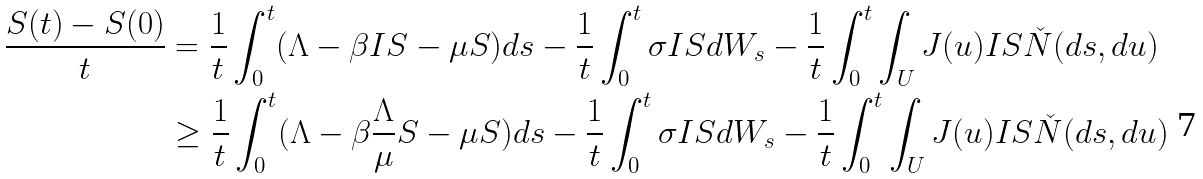Convert formula to latex. <formula><loc_0><loc_0><loc_500><loc_500>\frac { S ( t ) - S ( 0 ) } { t } & = \frac { 1 } { t } \int _ { 0 } ^ { t } ( \Lambda - \beta I S - \mu S ) d s - \frac { 1 } { t } \int _ { 0 } ^ { t } \sigma I S d W _ { s } - \frac { 1 } { t } \int _ { 0 } ^ { t } \int _ { U } J ( u ) I S \check { N } ( d s , d u ) \\ & \geq \frac { 1 } { t } \int _ { 0 } ^ { t } ( \Lambda - \beta \frac { \Lambda } { \mu } S - \mu S ) d s - \frac { 1 } { t } \int _ { 0 } ^ { t } \sigma I S d W _ { s } - \frac { 1 } { t } \int _ { 0 } ^ { t } \int _ { U } J ( u ) I S \check { N } ( d s , d u )</formula> 